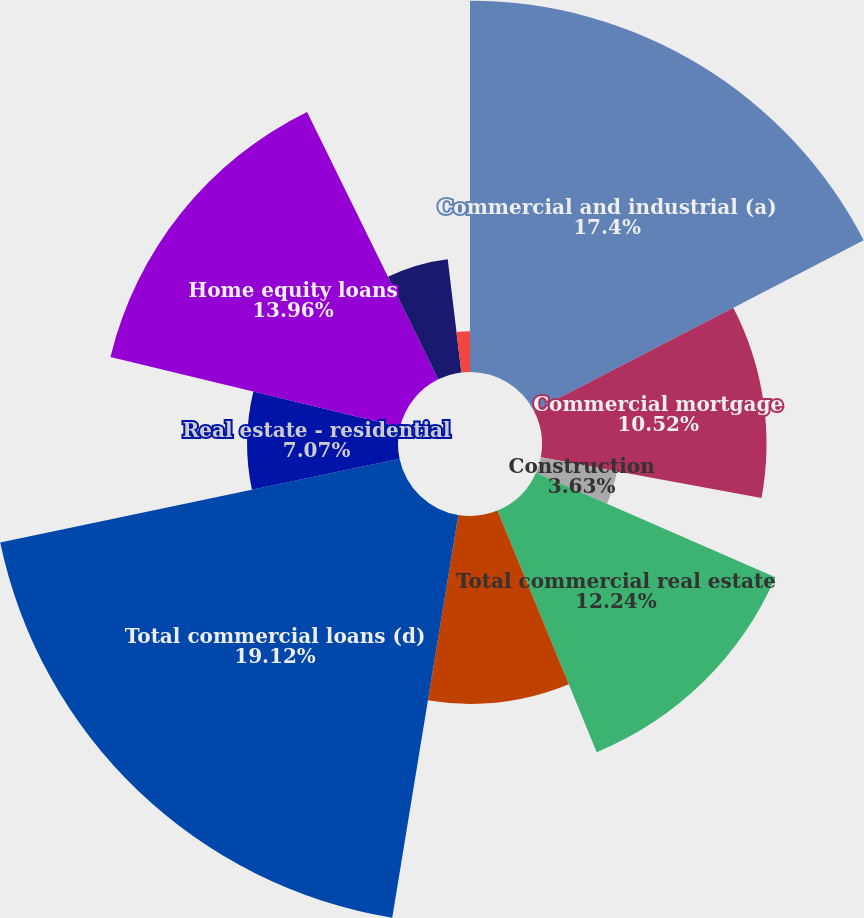<chart> <loc_0><loc_0><loc_500><loc_500><pie_chart><fcel>Commercial and industrial (a)<fcel>Commercial mortgage<fcel>Construction<fcel>Total commercial real estate<fcel>Commercial lease financing (c)<fcel>Total commercial loans (d)<fcel>Real estate - residential<fcel>Home equity loans<fcel>Consumer direct loans<fcel>Credit cards<nl><fcel>17.4%<fcel>10.52%<fcel>3.63%<fcel>12.24%<fcel>8.8%<fcel>19.12%<fcel>7.07%<fcel>13.96%<fcel>5.35%<fcel>1.91%<nl></chart> 